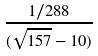Convert formula to latex. <formula><loc_0><loc_0><loc_500><loc_500>\frac { 1 / 2 8 8 } { ( \sqrt { 1 5 7 } - 1 0 ) }</formula> 